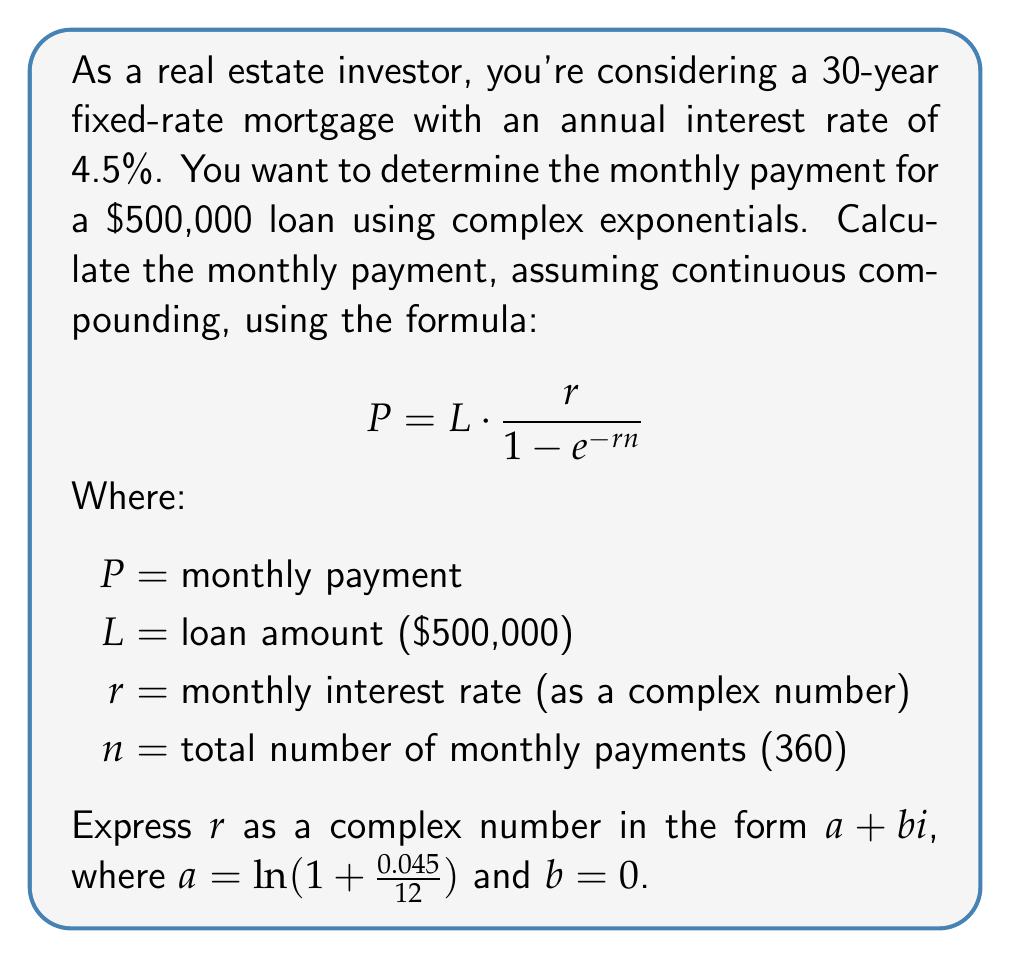Solve this math problem. To solve this problem, we'll follow these steps:

1) First, we need to calculate the monthly interest rate $r$ as a complex number:
   
   $r = \ln(1 + \frac{0.045}{12}) + 0i$
   
   $r = \ln(1.00375) + 0i$
   
   $r \approx 0.003741657386773941 + 0i$

2) Now we have all the components to plug into the formula:
   
   $L = 500,000$
   $r = 0.003741657386773941 + 0i$
   $n = 360$

3) Let's substitute these into the equation:

   $$P = 500,000 \cdot \frac{0.003741657386773941 + 0i}{1 - e^{-(0.003741657386773941 + 0i) \cdot 360}}$$

4) Simplify the exponent:
   
   $$P = 500,000 \cdot \frac{0.003741657386773941 + 0i}{1 - e^{-1.346996659237619 - 0i}}$$

5) Calculate $e^{-1.346996659237619}$:
   
   $$P = 500,000 \cdot \frac{0.003741657386773941 + 0i}{1 - 0.2600342050975417}$$

6) Simplify the denominator:
   
   $$P = 500,000 \cdot \frac{0.003741657386773941 + 0i}{0.7399657949024583}$$

7) Divide:
   
   $$P = 500,000 \cdot (0.005055068115631052 + 0i)$$

8) Multiply:
   
   $$P = 2527.534057815526 + 0i$$

The imaginary part is zero, so we can ignore it.
Answer: The monthly payment for the $500,000 loan with a 4.5% annual interest rate over 30 years, using continuous compounding, is approximately $2,527.53. 